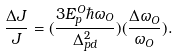Convert formula to latex. <formula><loc_0><loc_0><loc_500><loc_500>\frac { \Delta J } { J } = ( \frac { 3 E _ { p } ^ { O } \hbar { \omega } _ { O } } { \Delta _ { p d } ^ { 2 } } ) ( \frac { \Delta \omega _ { O } } { \omega _ { O } } ) .</formula> 